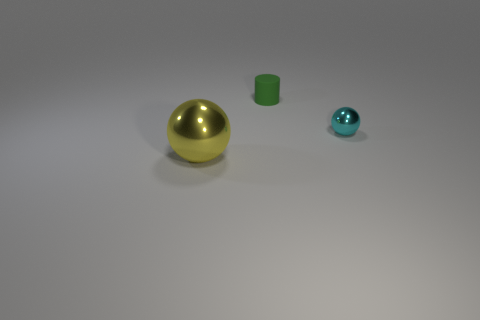What could these objects represent in an artistic composition? These objects could symbolize a range of concepts in an artistic composition. For instance, the size and color contrasts might represent diversity and individuality. The reflective surfaces suggest a theme of perception and reality, as they mirror their surroundings, potentially indicating introspection or self-examination. Further, the simplicity of the forms and their arrangement on an empty background could reflect isolation or highlight the importance of each object's unique characteristics. 